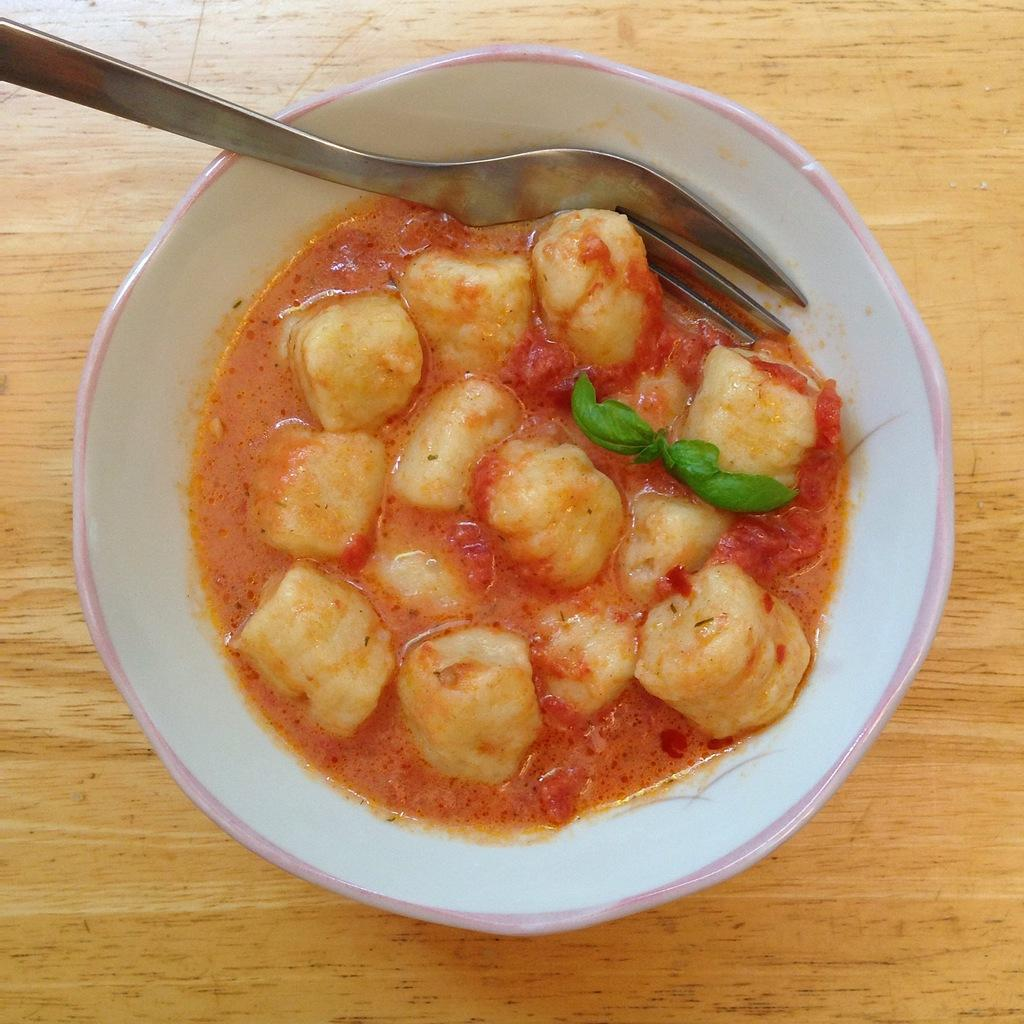What is the main subject of the image? There is a food item in the image. What utensil is present in the image? There is a spoon in the image. Where is the spoon located? The spoon is in a bowl. What is the bowl resting on? The bowl is on a platform. How many baseballs can be seen in the image? There are no baseballs present in the image. Is the bike visible in the image? There is no bike present in the image. 